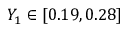<formula> <loc_0><loc_0><loc_500><loc_500>Y _ { 1 } \in [ 0 . 1 9 , 0 . 2 8 ]</formula> 